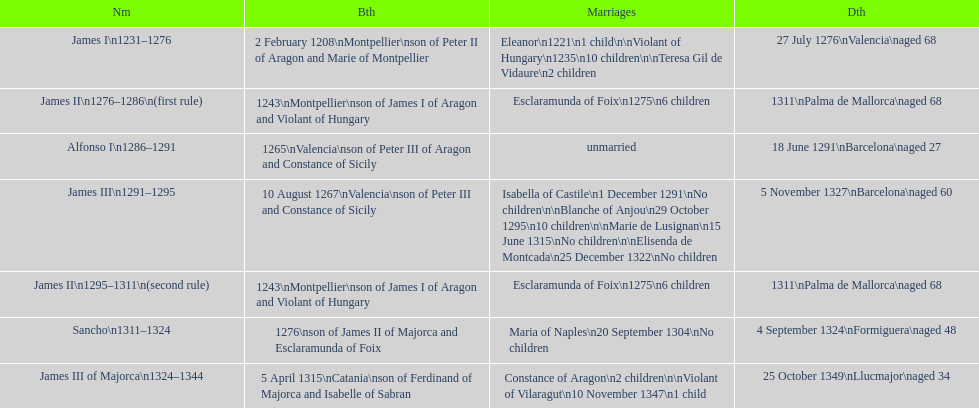How many of these monarchs died before the age of 65? 4. 